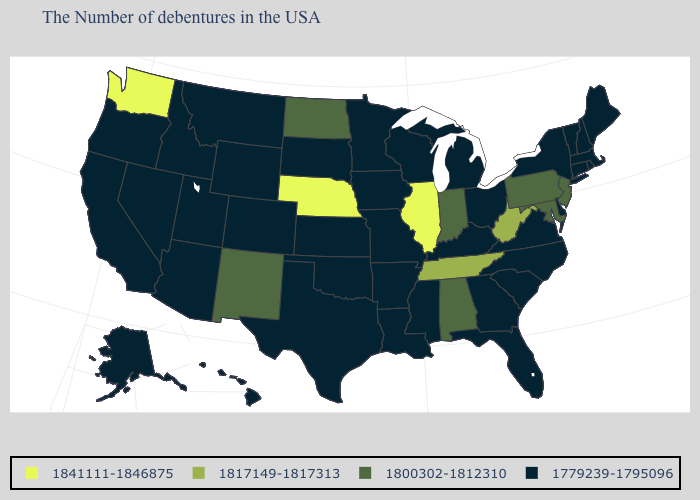What is the highest value in the USA?
Write a very short answer. 1841111-1846875. What is the value of Wisconsin?
Concise answer only. 1779239-1795096. Name the states that have a value in the range 1779239-1795096?
Keep it brief. Maine, Massachusetts, Rhode Island, New Hampshire, Vermont, Connecticut, New York, Delaware, Virginia, North Carolina, South Carolina, Ohio, Florida, Georgia, Michigan, Kentucky, Wisconsin, Mississippi, Louisiana, Missouri, Arkansas, Minnesota, Iowa, Kansas, Oklahoma, Texas, South Dakota, Wyoming, Colorado, Utah, Montana, Arizona, Idaho, Nevada, California, Oregon, Alaska, Hawaii. What is the value of Montana?
Keep it brief. 1779239-1795096. Does New Mexico have the lowest value in the USA?
Answer briefly. No. How many symbols are there in the legend?
Be succinct. 4. What is the value of Minnesota?
Give a very brief answer. 1779239-1795096. Does New Jersey have the lowest value in the USA?
Quick response, please. No. Name the states that have a value in the range 1817149-1817313?
Be succinct. West Virginia, Tennessee. Which states have the lowest value in the MidWest?
Short answer required. Ohio, Michigan, Wisconsin, Missouri, Minnesota, Iowa, Kansas, South Dakota. Name the states that have a value in the range 1779239-1795096?
Answer briefly. Maine, Massachusetts, Rhode Island, New Hampshire, Vermont, Connecticut, New York, Delaware, Virginia, North Carolina, South Carolina, Ohio, Florida, Georgia, Michigan, Kentucky, Wisconsin, Mississippi, Louisiana, Missouri, Arkansas, Minnesota, Iowa, Kansas, Oklahoma, Texas, South Dakota, Wyoming, Colorado, Utah, Montana, Arizona, Idaho, Nevada, California, Oregon, Alaska, Hawaii. Which states have the highest value in the USA?
Write a very short answer. Illinois, Nebraska, Washington. Does Illinois have the highest value in the MidWest?
Be succinct. Yes. Does Illinois have the highest value in the MidWest?
Quick response, please. Yes. 